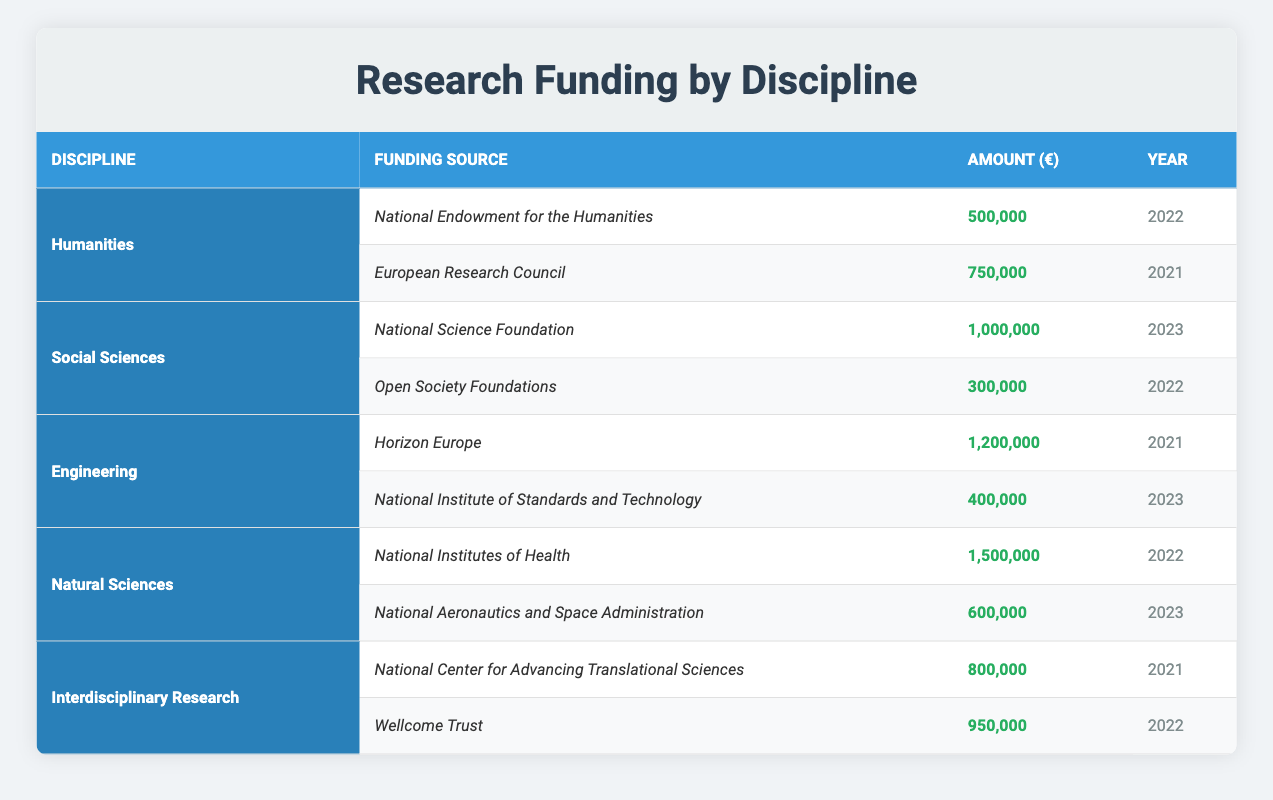What is the total funding amount for Humanities? The table shows two funding sources for Humanities: National Endowment for the Humanities (500,000) and European Research Council (750,000). Adding these amounts together gives 500,000 + 750,000 = 1,250,000.
Answer: 1,250,000 Which discipline received funding from the National Science Foundation? From the table, only Social Sciences lists National Science Foundation as a funding source with an amount of 1,000,000 in 2023.
Answer: Social Sciences What is the average funding amount for Engineering? Engineering has two funding sources: Horizon Europe (1,200,000) and National Institute of Standards and Technology (400,000). Summing these amounts gives 1,200,000 + 400,000 = 1,600,000. The average is calculated by dividing this total by 2 (the number of sources), which results in 1,600,000 / 2 = 800,000.
Answer: 800,000 Is the funding from the Wellcome Trust larger than the funding from the National Institute of Standards and Technology? The amount from Wellcome Trust is 950,000, while the amount from National Institute of Standards and Technology is 400,000. Since 950,000 is greater than 400,000, the answer is yes.
Answer: Yes What is the total funding amount for Natural Sciences and Interdisciplinary Research combined? The table lists Natural Sciences with two funding amounts: National Institutes of Health (1,500,000) and National Aeronautics and Space Administration (600,000), yielding a total of 1,500,000 + 600,000 = 2,100,000. Interdisciplinary Research also has two sources: National Center for Advancing Translational Sciences (800,000) and Wellcome Trust (950,000), totaling 800,000 + 950,000 = 1,750,000. Adding both totals gives 2,100,000 + 1,750,000 = 3,850,000.
Answer: 3,850,000 Which year saw the highest individual funding amount, and what was the source? Among all funding amounts listed, National Institutes of Health received the highest funding of 1,500,000 in 2022. This is confirmed by comparing it with all other amounts in the table.
Answer: 2022, National Institutes of Health 